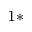<formula> <loc_0><loc_0><loc_500><loc_500>^ { 1 \ast }</formula> 